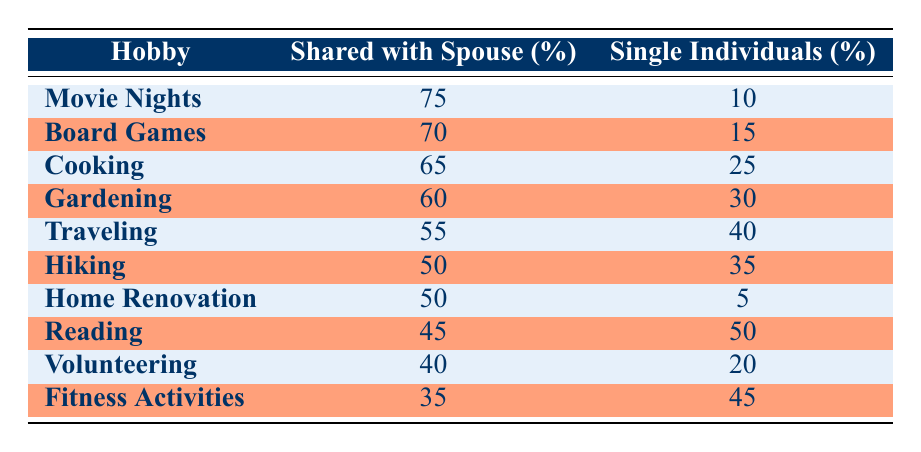What hobby has the highest percentage of individuals sharing it with their spouse? The hobby with the highest percentage of individuals sharing it with their spouse is "Movie Nights" at 75%. This can be seen by looking through the "Shared with Spouse (%)" column and identifying the maximum value.
Answer: Movie Nights What is the percentage of single individuals who enjoy Cooking? The percentage of single individuals who enjoy Cooking is 25%. This value can be found in the "Single Individuals (%)" column corresponding to the "Cooking" hobby row.
Answer: 25 How many hobbies have more than 50% of individuals sharing them with their spouse? There are 5 hobbies that have more than 50% of individuals sharing them with their spouse: Movie Nights, Board Games, Cooking, Gardening, and Traveling. This can be determined by counting the rows where the "Shared with Spouse (%)" value exceeds 50.
Answer: 5 What is the difference in percentage of single individuals enjoying Reading versus those enjoying Fitness Activities? The percentage of single individuals enjoying Reading is 50%, while for Fitness Activities, it is 45%. The difference can be calculated as 50 - 45 = 5.
Answer: 5 Is it true that more single individuals enjoy Gardening than enjoy Movie Nights? No, that statement is false. Single individuals enjoying Gardening is 30%, and for Movie Nights, it is only 10%. By comparing these two values, Gardening has a higher percentage of single individuals enjoying it.
Answer: No What is the average percentage of individuals sharing their hobbies with a spouse across all listed hobbies? To find the average percentage shared with a spouse, we sum all the shared percentages: 75 + 70 + 65 + 60 + 55 + 50 + 50 + 45 + 40 + 35 =  670. Then, divide by the number of hobbies (10), which results in an average of 670/10 = 67%.
Answer: 67 Which hobby has the lowest percentage of individuals sharing it with their spouse? The hobby with the lowest percentage of individuals sharing it with their spouse is "Fitness Activities" at 35%. This is determined by identifying the minimum value in the "Shared with Spouse (%)" column.
Answer: Fitness Activities How many hobbies out of the list have fewer than 20% of single individuals enjoying them? There are 2 hobbies with fewer than 20% of single individuals enjoying them: Home Renovation (5%) and Movie Nights (10%). By reviewing the "Single Individuals (%)" column and counting the values below 20%, we find these two matches.
Answer: 2 